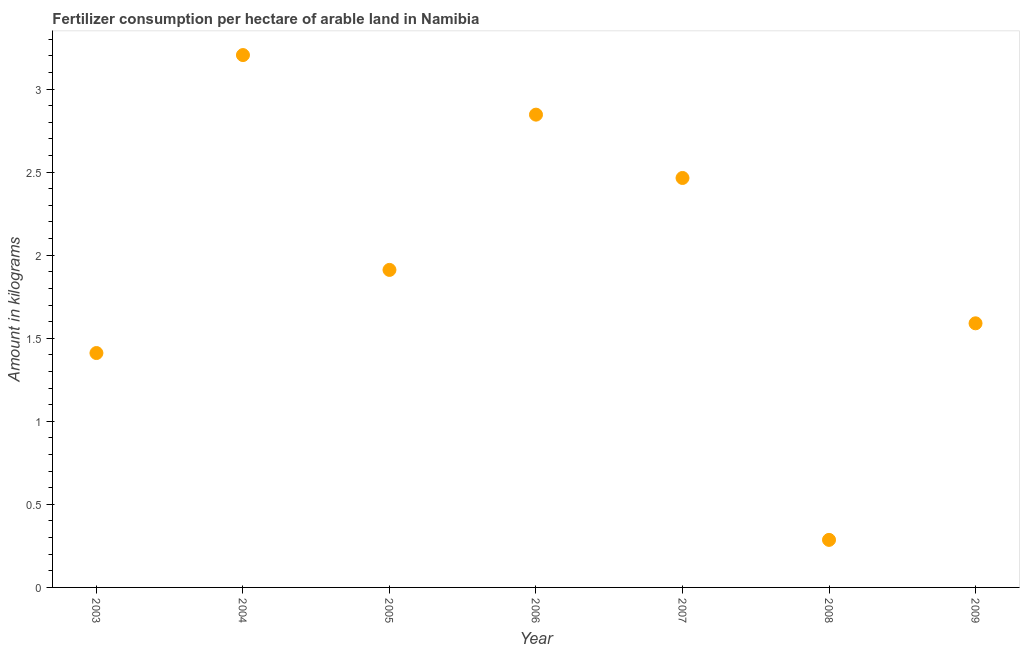What is the amount of fertilizer consumption in 2009?
Provide a succinct answer. 1.59. Across all years, what is the maximum amount of fertilizer consumption?
Your answer should be very brief. 3.2. Across all years, what is the minimum amount of fertilizer consumption?
Your response must be concise. 0.29. In which year was the amount of fertilizer consumption minimum?
Offer a terse response. 2008. What is the sum of the amount of fertilizer consumption?
Provide a short and direct response. 13.71. What is the difference between the amount of fertilizer consumption in 2003 and 2006?
Keep it short and to the point. -1.44. What is the average amount of fertilizer consumption per year?
Give a very brief answer. 1.96. What is the median amount of fertilizer consumption?
Your response must be concise. 1.91. In how many years, is the amount of fertilizer consumption greater than 2.6 kg?
Provide a short and direct response. 2. What is the ratio of the amount of fertilizer consumption in 2007 to that in 2008?
Provide a succinct answer. 8.61. Is the amount of fertilizer consumption in 2003 less than that in 2009?
Your answer should be very brief. Yes. Is the difference between the amount of fertilizer consumption in 2003 and 2006 greater than the difference between any two years?
Offer a terse response. No. What is the difference between the highest and the second highest amount of fertilizer consumption?
Keep it short and to the point. 0.36. Is the sum of the amount of fertilizer consumption in 2003 and 2009 greater than the maximum amount of fertilizer consumption across all years?
Offer a terse response. No. What is the difference between the highest and the lowest amount of fertilizer consumption?
Provide a succinct answer. 2.92. In how many years, is the amount of fertilizer consumption greater than the average amount of fertilizer consumption taken over all years?
Keep it short and to the point. 3. Does the amount of fertilizer consumption monotonically increase over the years?
Offer a very short reply. No. How many dotlines are there?
Give a very brief answer. 1. What is the difference between two consecutive major ticks on the Y-axis?
Ensure brevity in your answer.  0.5. What is the title of the graph?
Your response must be concise. Fertilizer consumption per hectare of arable land in Namibia . What is the label or title of the Y-axis?
Keep it short and to the point. Amount in kilograms. What is the Amount in kilograms in 2003?
Make the answer very short. 1.41. What is the Amount in kilograms in 2004?
Provide a succinct answer. 3.2. What is the Amount in kilograms in 2005?
Give a very brief answer. 1.91. What is the Amount in kilograms in 2006?
Give a very brief answer. 2.85. What is the Amount in kilograms in 2007?
Offer a terse response. 2.46. What is the Amount in kilograms in 2008?
Offer a terse response. 0.29. What is the Amount in kilograms in 2009?
Offer a very short reply. 1.59. What is the difference between the Amount in kilograms in 2003 and 2004?
Ensure brevity in your answer.  -1.79. What is the difference between the Amount in kilograms in 2003 and 2005?
Ensure brevity in your answer.  -0.5. What is the difference between the Amount in kilograms in 2003 and 2006?
Provide a short and direct response. -1.44. What is the difference between the Amount in kilograms in 2003 and 2007?
Keep it short and to the point. -1.05. What is the difference between the Amount in kilograms in 2003 and 2008?
Your response must be concise. 1.12. What is the difference between the Amount in kilograms in 2003 and 2009?
Provide a short and direct response. -0.18. What is the difference between the Amount in kilograms in 2004 and 2005?
Keep it short and to the point. 1.29. What is the difference between the Amount in kilograms in 2004 and 2006?
Give a very brief answer. 0.36. What is the difference between the Amount in kilograms in 2004 and 2007?
Offer a very short reply. 0.74. What is the difference between the Amount in kilograms in 2004 and 2008?
Provide a succinct answer. 2.92. What is the difference between the Amount in kilograms in 2004 and 2009?
Provide a short and direct response. 1.61. What is the difference between the Amount in kilograms in 2005 and 2006?
Provide a succinct answer. -0.93. What is the difference between the Amount in kilograms in 2005 and 2007?
Offer a terse response. -0.55. What is the difference between the Amount in kilograms in 2005 and 2008?
Offer a terse response. 1.63. What is the difference between the Amount in kilograms in 2005 and 2009?
Provide a succinct answer. 0.32. What is the difference between the Amount in kilograms in 2006 and 2007?
Your answer should be compact. 0.38. What is the difference between the Amount in kilograms in 2006 and 2008?
Give a very brief answer. 2.56. What is the difference between the Amount in kilograms in 2006 and 2009?
Your answer should be very brief. 1.26. What is the difference between the Amount in kilograms in 2007 and 2008?
Your answer should be compact. 2.18. What is the difference between the Amount in kilograms in 2007 and 2009?
Your answer should be very brief. 0.88. What is the difference between the Amount in kilograms in 2008 and 2009?
Offer a terse response. -1.3. What is the ratio of the Amount in kilograms in 2003 to that in 2004?
Your answer should be compact. 0.44. What is the ratio of the Amount in kilograms in 2003 to that in 2005?
Keep it short and to the point. 0.74. What is the ratio of the Amount in kilograms in 2003 to that in 2006?
Give a very brief answer. 0.5. What is the ratio of the Amount in kilograms in 2003 to that in 2007?
Your answer should be very brief. 0.57. What is the ratio of the Amount in kilograms in 2003 to that in 2008?
Provide a short and direct response. 4.93. What is the ratio of the Amount in kilograms in 2003 to that in 2009?
Offer a very short reply. 0.89. What is the ratio of the Amount in kilograms in 2004 to that in 2005?
Keep it short and to the point. 1.68. What is the ratio of the Amount in kilograms in 2004 to that in 2006?
Give a very brief answer. 1.13. What is the ratio of the Amount in kilograms in 2004 to that in 2007?
Your answer should be very brief. 1.3. What is the ratio of the Amount in kilograms in 2004 to that in 2008?
Offer a terse response. 11.2. What is the ratio of the Amount in kilograms in 2004 to that in 2009?
Your response must be concise. 2.02. What is the ratio of the Amount in kilograms in 2005 to that in 2006?
Your answer should be compact. 0.67. What is the ratio of the Amount in kilograms in 2005 to that in 2007?
Offer a very short reply. 0.78. What is the ratio of the Amount in kilograms in 2005 to that in 2008?
Give a very brief answer. 6.68. What is the ratio of the Amount in kilograms in 2005 to that in 2009?
Provide a short and direct response. 1.2. What is the ratio of the Amount in kilograms in 2006 to that in 2007?
Your answer should be very brief. 1.16. What is the ratio of the Amount in kilograms in 2006 to that in 2008?
Provide a succinct answer. 9.94. What is the ratio of the Amount in kilograms in 2006 to that in 2009?
Provide a succinct answer. 1.79. What is the ratio of the Amount in kilograms in 2007 to that in 2008?
Your response must be concise. 8.61. What is the ratio of the Amount in kilograms in 2007 to that in 2009?
Offer a very short reply. 1.55. What is the ratio of the Amount in kilograms in 2008 to that in 2009?
Ensure brevity in your answer.  0.18. 